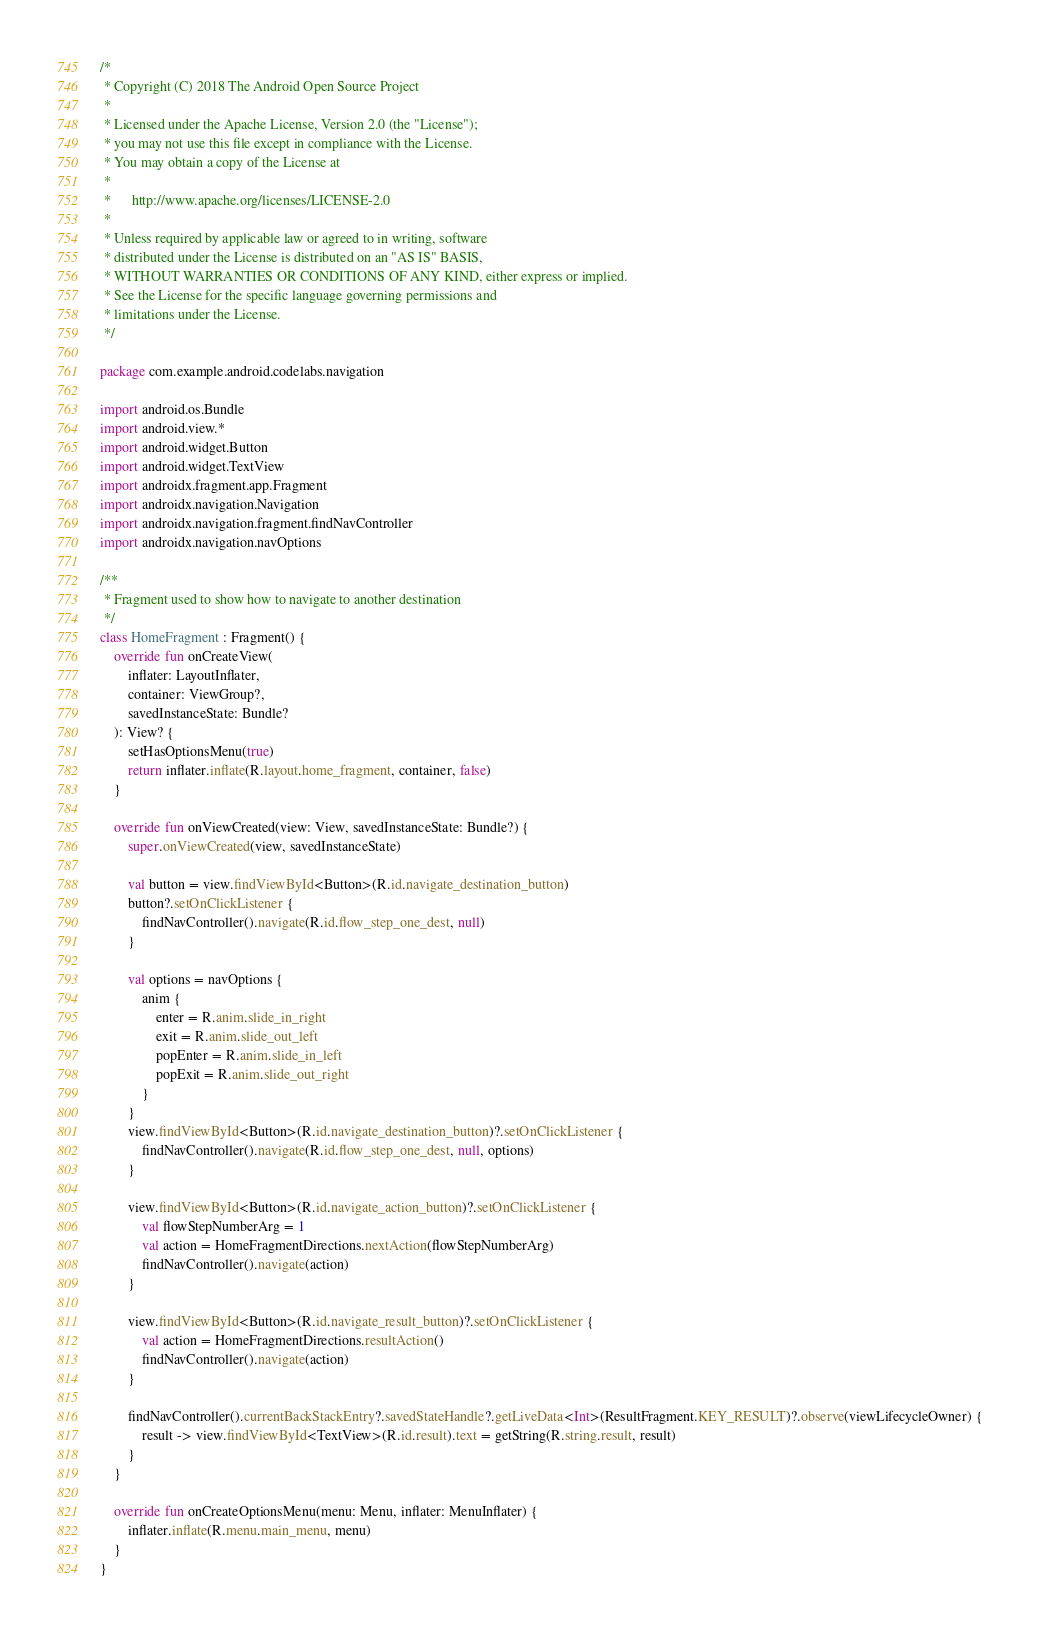Convert code to text. <code><loc_0><loc_0><loc_500><loc_500><_Kotlin_>/*
 * Copyright (C) 2018 The Android Open Source Project
 *
 * Licensed under the Apache License, Version 2.0 (the "License");
 * you may not use this file except in compliance with the License.
 * You may obtain a copy of the License at
 *
 *      http://www.apache.org/licenses/LICENSE-2.0
 *
 * Unless required by applicable law or agreed to in writing, software
 * distributed under the License is distributed on an "AS IS" BASIS,
 * WITHOUT WARRANTIES OR CONDITIONS OF ANY KIND, either express or implied.
 * See the License for the specific language governing permissions and
 * limitations under the License.
 */

package com.example.android.codelabs.navigation

import android.os.Bundle
import android.view.*
import android.widget.Button
import android.widget.TextView
import androidx.fragment.app.Fragment
import androidx.navigation.Navigation
import androidx.navigation.fragment.findNavController
import androidx.navigation.navOptions

/**
 * Fragment used to show how to navigate to another destination
 */
class HomeFragment : Fragment() {
    override fun onCreateView(
        inflater: LayoutInflater,
        container: ViewGroup?,
        savedInstanceState: Bundle?
    ): View? {
        setHasOptionsMenu(true)
        return inflater.inflate(R.layout.home_fragment, container, false)
    }

    override fun onViewCreated(view: View, savedInstanceState: Bundle?) {
        super.onViewCreated(view, savedInstanceState)

        val button = view.findViewById<Button>(R.id.navigate_destination_button)
        button?.setOnClickListener {
            findNavController().navigate(R.id.flow_step_one_dest, null)
        }

        val options = navOptions {
            anim {
                enter = R.anim.slide_in_right
                exit = R.anim.slide_out_left
                popEnter = R.anim.slide_in_left
                popExit = R.anim.slide_out_right
            }
        }
        view.findViewById<Button>(R.id.navigate_destination_button)?.setOnClickListener {
            findNavController().navigate(R.id.flow_step_one_dest, null, options)
        }

        view.findViewById<Button>(R.id.navigate_action_button)?.setOnClickListener {
            val flowStepNumberArg = 1
            val action = HomeFragmentDirections.nextAction(flowStepNumberArg)
            findNavController().navigate(action)
        }

        view.findViewById<Button>(R.id.navigate_result_button)?.setOnClickListener {
            val action = HomeFragmentDirections.resultAction()
            findNavController().navigate(action)
        }

        findNavController().currentBackStackEntry?.savedStateHandle?.getLiveData<Int>(ResultFragment.KEY_RESULT)?.observe(viewLifecycleOwner) {
            result -> view.findViewById<TextView>(R.id.result).text = getString(R.string.result, result)
        }
    }

    override fun onCreateOptionsMenu(menu: Menu, inflater: MenuInflater) {
        inflater.inflate(R.menu.main_menu, menu)
    }
}
</code> 